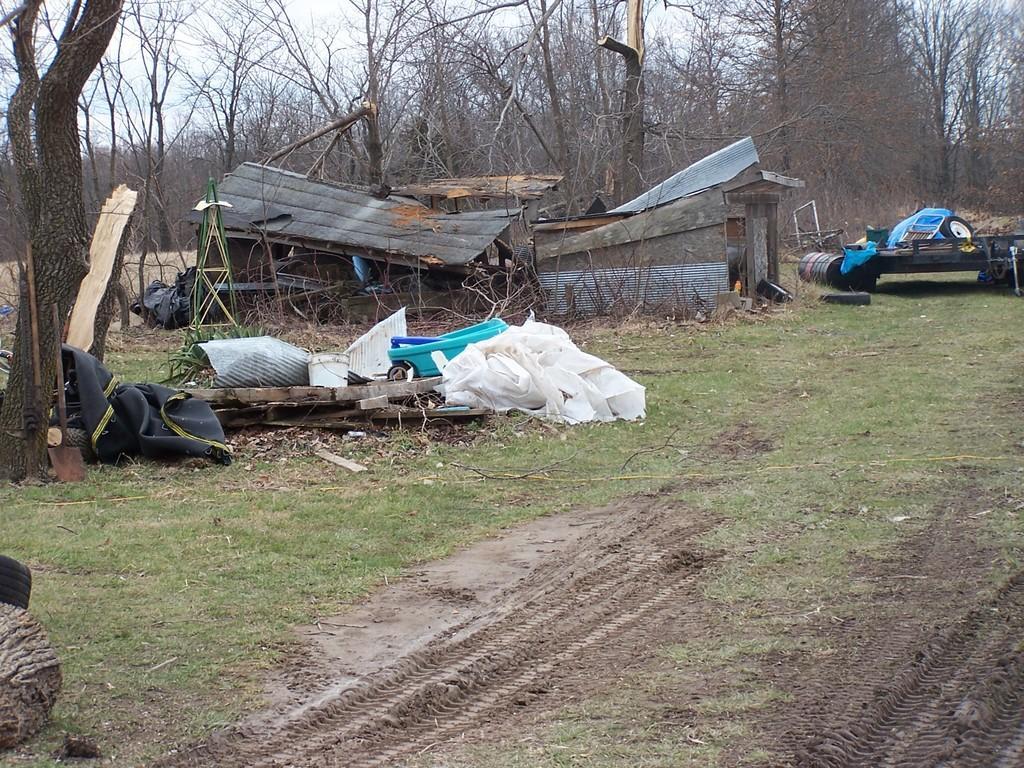How would you summarize this image in a sentence or two? In this picture we can observe a destroyed house. We can observe white color cloth. There is some grass on the ground. In the background there are trees and a sky. 